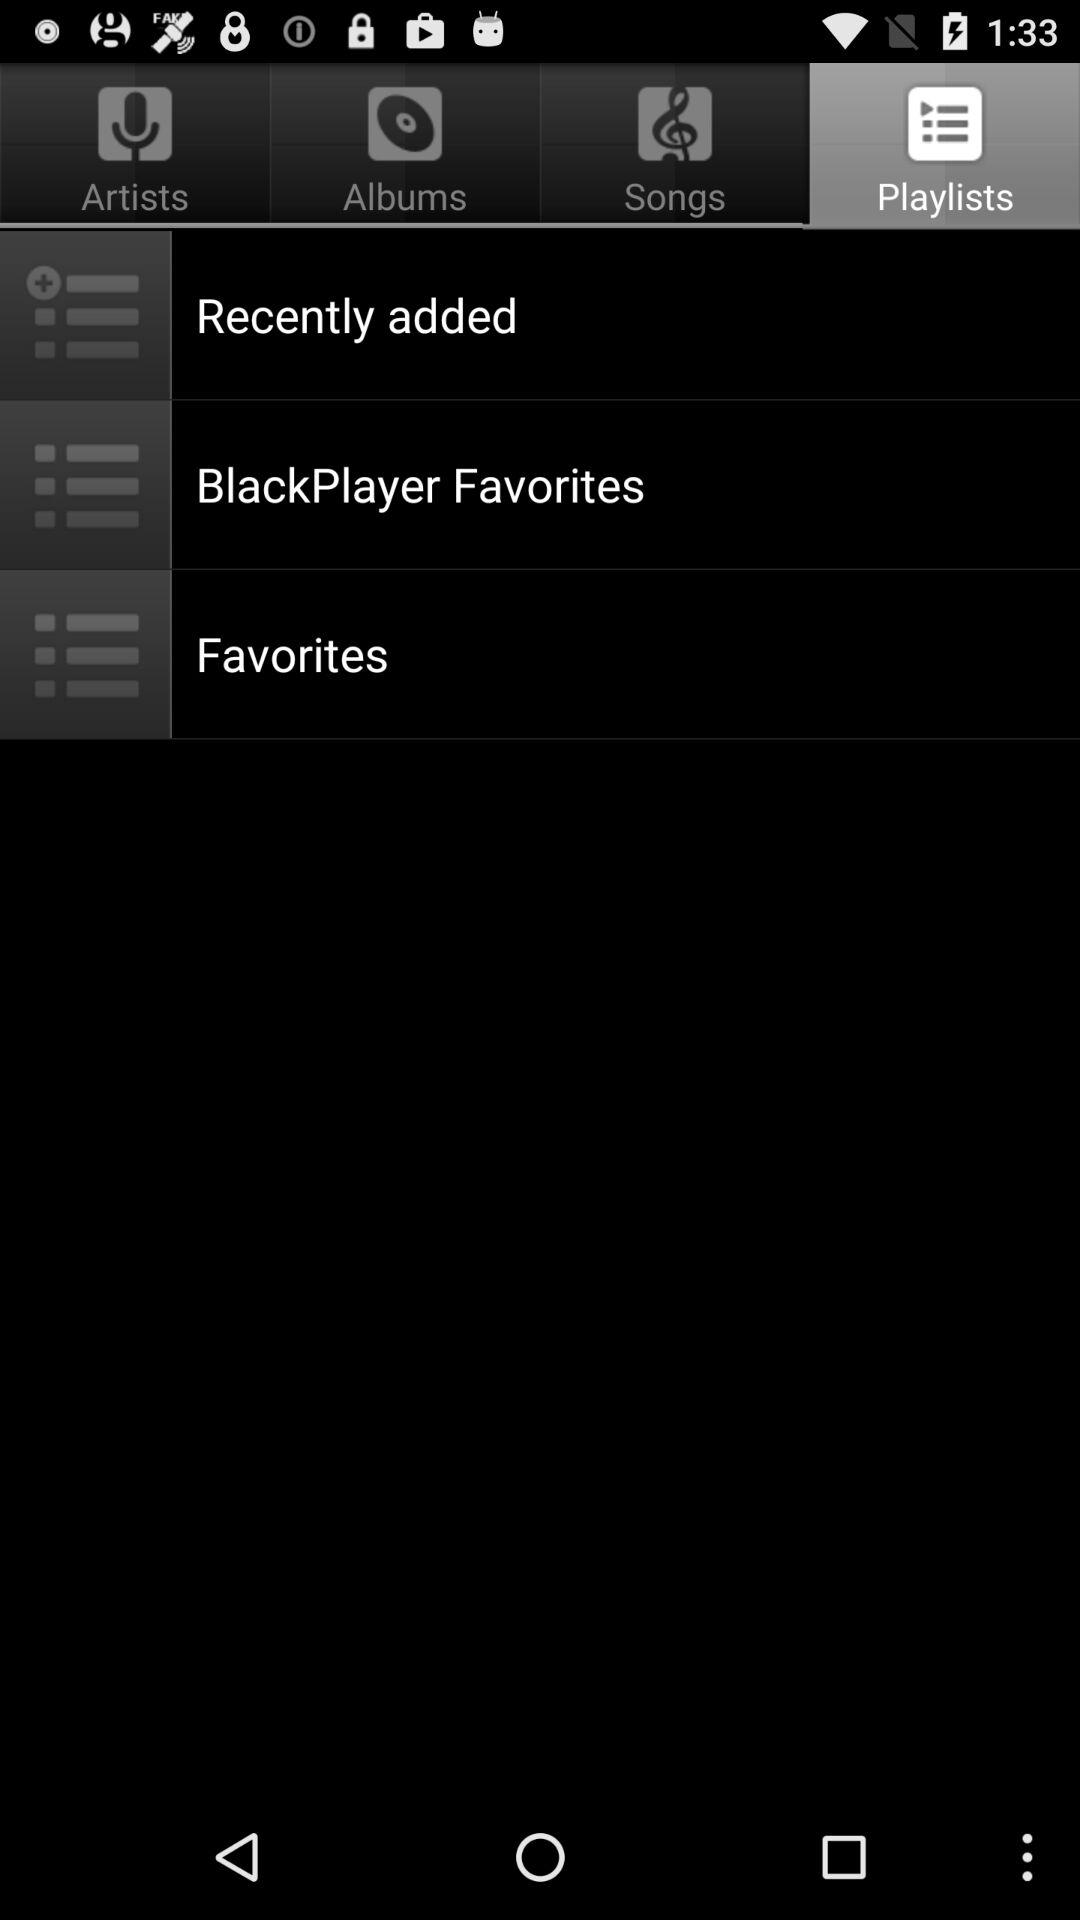Which songs are in the "Songs" tab?
When the provided information is insufficient, respond with <no answer>. <no answer> 